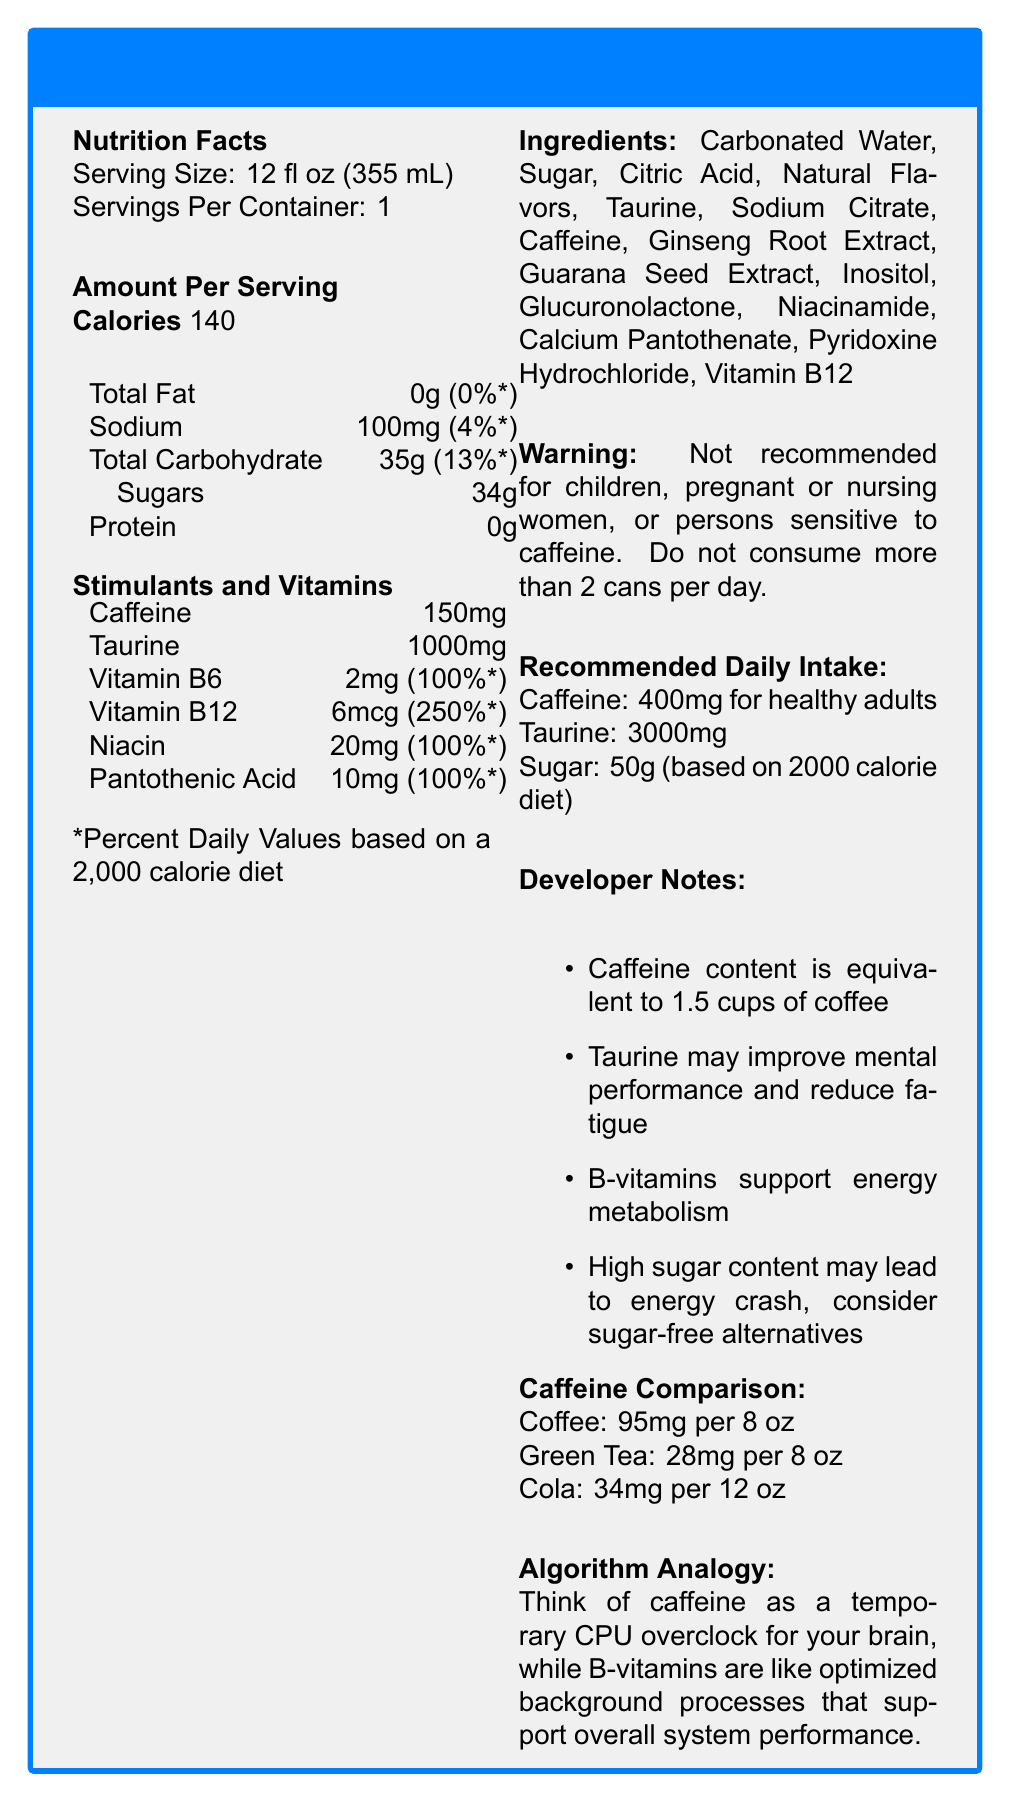what is the serving size of CodeRush Energy Drink? The serving size is explicitly mentioned at the beginning of the Nutrition Facts section.
Answer: 12 fl oz (355 mL) how much caffeine does one serving of CodeRush Energy Drink contain? The caffeine content is listed under the "Stimulants and Vitamins" section.
Answer: 150 mg what is the daily recommended intake for caffeine for healthy adults? The recommended daily intake for caffeine is clearly stated in the "Recommended Daily Intake" section.
Answer: 400 mg how many grams of sugar are there per serving of CodeRush Energy Drink? The sugar content is mentioned under the "Amount Per Serving" section under "Total Carbohydrate".
Answer: 34 g what percentage of the daily value for vitamin B12 does one serving of CodeRush Energy Drink provide? The percentage of the daily value for vitamin B12 is listed in the "Stimulants and Vitamins" section.
Answer: 250%* how much sodium is in a serving, and what percentage of the daily value does it represent? The sodium content is 100 mg and it represents 4% of the daily value, as listed in the "Amount Per Serving" section.
Answer: 100 mg, 4% which ingredient is listed first on the ingredients list? The first ingredient listed is "Carbonated Water" under the "Ingredients" section.
Answer: Carbonated Water how does the caffeine content in CodeRush Energy Drink compare to that in cola? (Choose one) A. Higher B. Lower C. About the same CodeRush contains 150 mg of caffeine per serving, whereas cola contains 34 mg per 12 oz, as stated in the "Caffeine Comparison" section.
Answer: A. Higher what is the equivalent caffeine content of CodeRush in terms of cups of coffee? (Choose one) A. 1 cup B. 1.5 cups C. 2 cups The document notes that the caffeine content in CodeRush is equivalent to 1.5 cups of coffee.
Answer: B. 1.5 cups is CodeRush Energy Drink recommended for children? The warning section clearly states, "Not recommended for children, pregnant or nursing women, or persons sensitive to caffeine."
Answer: No briefly summarize the main features of CodeRush Energy Drink The summary covers the key points outlined in various sections of the document, including the nutrition facts, stimulants, warnings, and additional notes provided.
Answer: CodeRush Energy Drink is a caffeine-infused beverage with 150 mg of caffeine and 1000 mg of taurine per serving. It contains B-vitamins that support energy metabolism but has a high sugar content (34 g). The document includes recommended daily intakes, a warning for certain groups, and a comparison of caffeine content with other beverages. what is the amount of potassium in a serving of CodeRush Energy Drink? The amount of potassium is not mentioned in the document, so we cannot determine it from the given information.
Answer: Not enough information 